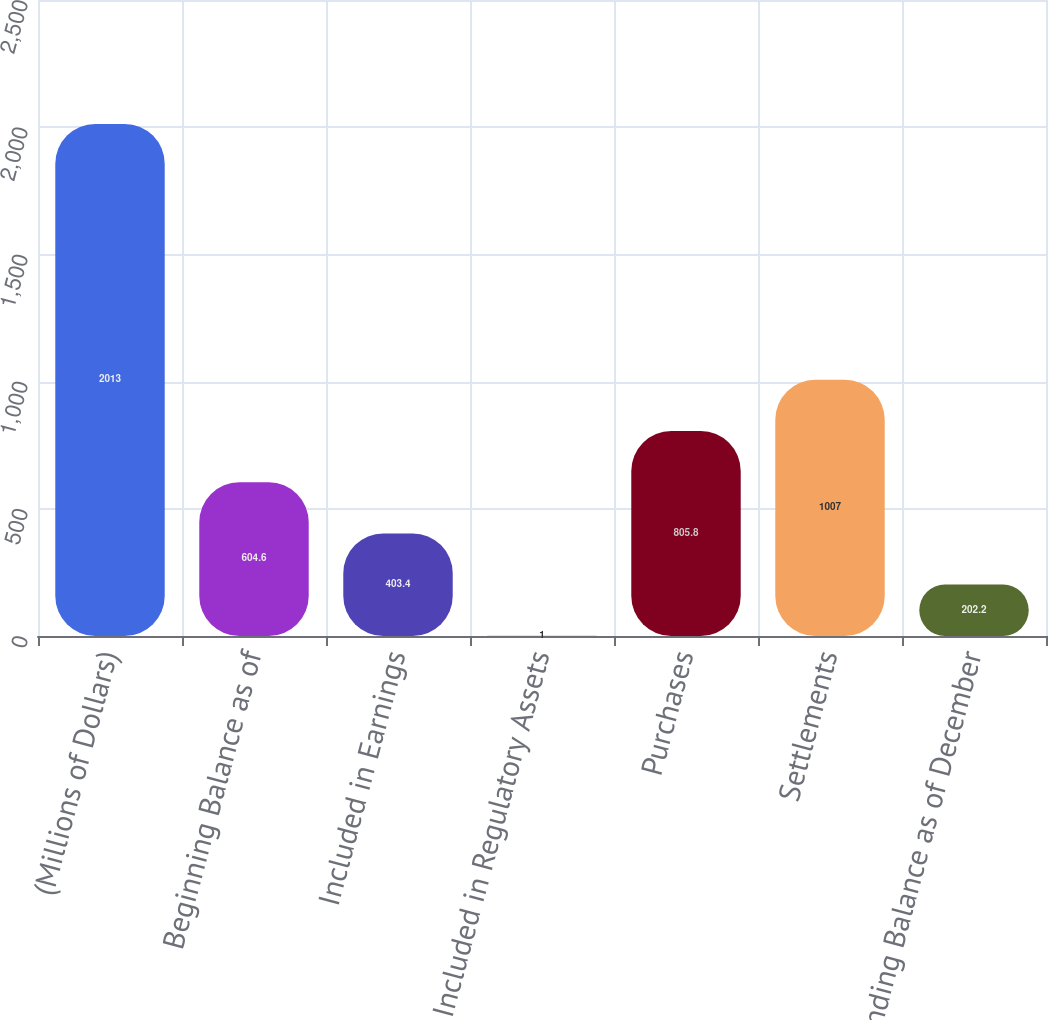Convert chart. <chart><loc_0><loc_0><loc_500><loc_500><bar_chart><fcel>(Millions of Dollars)<fcel>Beginning Balance as of<fcel>Included in Earnings<fcel>Included in Regulatory Assets<fcel>Purchases<fcel>Settlements<fcel>Ending Balance as of December<nl><fcel>2013<fcel>604.6<fcel>403.4<fcel>1<fcel>805.8<fcel>1007<fcel>202.2<nl></chart> 